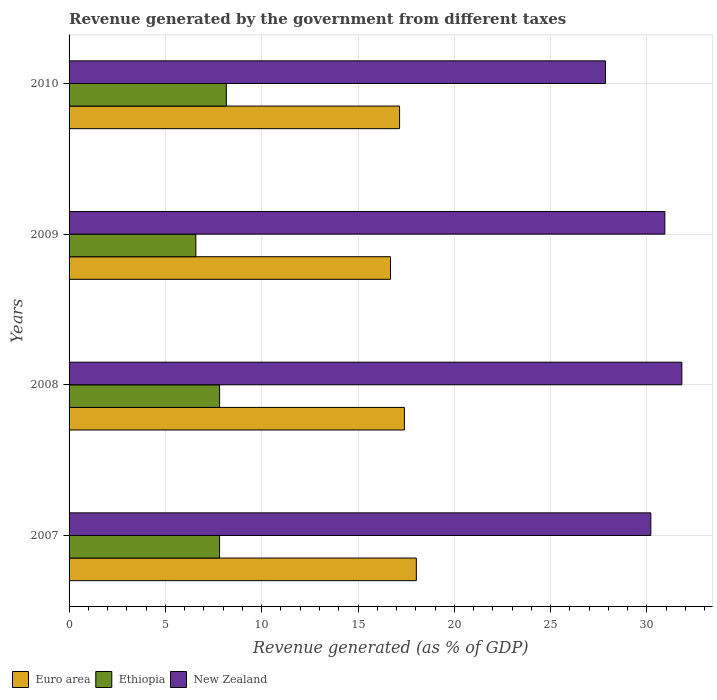How many different coloured bars are there?
Provide a succinct answer. 3. How many groups of bars are there?
Ensure brevity in your answer.  4. Are the number of bars per tick equal to the number of legend labels?
Your answer should be very brief. Yes. Are the number of bars on each tick of the Y-axis equal?
Your response must be concise. Yes. What is the label of the 2nd group of bars from the top?
Make the answer very short. 2009. In how many cases, is the number of bars for a given year not equal to the number of legend labels?
Make the answer very short. 0. What is the revenue generated by the government in Euro area in 2009?
Your answer should be compact. 16.69. Across all years, what is the maximum revenue generated by the government in Ethiopia?
Offer a very short reply. 8.16. Across all years, what is the minimum revenue generated by the government in Ethiopia?
Provide a succinct answer. 6.58. In which year was the revenue generated by the government in New Zealand minimum?
Give a very brief answer. 2010. What is the total revenue generated by the government in Euro area in the graph?
Provide a short and direct response. 69.28. What is the difference between the revenue generated by the government in New Zealand in 2007 and that in 2008?
Your answer should be compact. -1.61. What is the difference between the revenue generated by the government in Euro area in 2010 and the revenue generated by the government in Ethiopia in 2007?
Give a very brief answer. 9.35. What is the average revenue generated by the government in Euro area per year?
Ensure brevity in your answer.  17.32. In the year 2008, what is the difference between the revenue generated by the government in Ethiopia and revenue generated by the government in New Zealand?
Your answer should be very brief. -24. What is the ratio of the revenue generated by the government in New Zealand in 2007 to that in 2008?
Offer a very short reply. 0.95. Is the revenue generated by the government in Ethiopia in 2009 less than that in 2010?
Your response must be concise. Yes. Is the difference between the revenue generated by the government in Ethiopia in 2007 and 2009 greater than the difference between the revenue generated by the government in New Zealand in 2007 and 2009?
Provide a succinct answer. Yes. What is the difference between the highest and the second highest revenue generated by the government in Ethiopia?
Keep it short and to the point. 0.35. What is the difference between the highest and the lowest revenue generated by the government in Euro area?
Keep it short and to the point. 1.34. In how many years, is the revenue generated by the government in Ethiopia greater than the average revenue generated by the government in Ethiopia taken over all years?
Ensure brevity in your answer.  3. Is the sum of the revenue generated by the government in Ethiopia in 2007 and 2008 greater than the maximum revenue generated by the government in Euro area across all years?
Provide a succinct answer. No. What does the 1st bar from the top in 2007 represents?
Provide a short and direct response. New Zealand. What does the 2nd bar from the bottom in 2007 represents?
Offer a very short reply. Ethiopia. Are all the bars in the graph horizontal?
Provide a succinct answer. Yes. How many years are there in the graph?
Keep it short and to the point. 4. Are the values on the major ticks of X-axis written in scientific E-notation?
Your answer should be very brief. No. What is the title of the graph?
Ensure brevity in your answer.  Revenue generated by the government from different taxes. Does "Cyprus" appear as one of the legend labels in the graph?
Ensure brevity in your answer.  No. What is the label or title of the X-axis?
Provide a succinct answer. Revenue generated (as % of GDP). What is the label or title of the Y-axis?
Provide a short and direct response. Years. What is the Revenue generated (as % of GDP) in Euro area in 2007?
Your answer should be compact. 18.03. What is the Revenue generated (as % of GDP) in Ethiopia in 2007?
Ensure brevity in your answer.  7.81. What is the Revenue generated (as % of GDP) of New Zealand in 2007?
Make the answer very short. 30.2. What is the Revenue generated (as % of GDP) of Euro area in 2008?
Your response must be concise. 17.41. What is the Revenue generated (as % of GDP) of Ethiopia in 2008?
Your response must be concise. 7.81. What is the Revenue generated (as % of GDP) in New Zealand in 2008?
Give a very brief answer. 31.81. What is the Revenue generated (as % of GDP) in Euro area in 2009?
Offer a very short reply. 16.69. What is the Revenue generated (as % of GDP) in Ethiopia in 2009?
Give a very brief answer. 6.58. What is the Revenue generated (as % of GDP) in New Zealand in 2009?
Your answer should be very brief. 30.93. What is the Revenue generated (as % of GDP) in Euro area in 2010?
Your answer should be compact. 17.16. What is the Revenue generated (as % of GDP) in Ethiopia in 2010?
Give a very brief answer. 8.16. What is the Revenue generated (as % of GDP) in New Zealand in 2010?
Offer a terse response. 27.85. Across all years, what is the maximum Revenue generated (as % of GDP) of Euro area?
Your answer should be very brief. 18.03. Across all years, what is the maximum Revenue generated (as % of GDP) in Ethiopia?
Make the answer very short. 8.16. Across all years, what is the maximum Revenue generated (as % of GDP) in New Zealand?
Keep it short and to the point. 31.81. Across all years, what is the minimum Revenue generated (as % of GDP) of Euro area?
Your response must be concise. 16.69. Across all years, what is the minimum Revenue generated (as % of GDP) of Ethiopia?
Ensure brevity in your answer.  6.58. Across all years, what is the minimum Revenue generated (as % of GDP) of New Zealand?
Offer a very short reply. 27.85. What is the total Revenue generated (as % of GDP) in Euro area in the graph?
Make the answer very short. 69.28. What is the total Revenue generated (as % of GDP) of Ethiopia in the graph?
Ensure brevity in your answer.  30.37. What is the total Revenue generated (as % of GDP) in New Zealand in the graph?
Provide a short and direct response. 120.79. What is the difference between the Revenue generated (as % of GDP) of Euro area in 2007 and that in 2008?
Provide a short and direct response. 0.62. What is the difference between the Revenue generated (as % of GDP) in Ethiopia in 2007 and that in 2008?
Offer a terse response. -0. What is the difference between the Revenue generated (as % of GDP) in New Zealand in 2007 and that in 2008?
Your answer should be very brief. -1.61. What is the difference between the Revenue generated (as % of GDP) of Euro area in 2007 and that in 2009?
Keep it short and to the point. 1.34. What is the difference between the Revenue generated (as % of GDP) of Ethiopia in 2007 and that in 2009?
Your answer should be compact. 1.23. What is the difference between the Revenue generated (as % of GDP) of New Zealand in 2007 and that in 2009?
Your answer should be compact. -0.73. What is the difference between the Revenue generated (as % of GDP) in Euro area in 2007 and that in 2010?
Provide a succinct answer. 0.87. What is the difference between the Revenue generated (as % of GDP) of Ethiopia in 2007 and that in 2010?
Offer a very short reply. -0.35. What is the difference between the Revenue generated (as % of GDP) of New Zealand in 2007 and that in 2010?
Your answer should be compact. 2.35. What is the difference between the Revenue generated (as % of GDP) of Euro area in 2008 and that in 2009?
Give a very brief answer. 0.72. What is the difference between the Revenue generated (as % of GDP) in Ethiopia in 2008 and that in 2009?
Your response must be concise. 1.23. What is the difference between the Revenue generated (as % of GDP) in New Zealand in 2008 and that in 2009?
Offer a very short reply. 0.88. What is the difference between the Revenue generated (as % of GDP) in Euro area in 2008 and that in 2010?
Your answer should be compact. 0.25. What is the difference between the Revenue generated (as % of GDP) of Ethiopia in 2008 and that in 2010?
Offer a very short reply. -0.35. What is the difference between the Revenue generated (as % of GDP) of New Zealand in 2008 and that in 2010?
Your answer should be compact. 3.96. What is the difference between the Revenue generated (as % of GDP) in Euro area in 2009 and that in 2010?
Ensure brevity in your answer.  -0.47. What is the difference between the Revenue generated (as % of GDP) of Ethiopia in 2009 and that in 2010?
Make the answer very short. -1.58. What is the difference between the Revenue generated (as % of GDP) in New Zealand in 2009 and that in 2010?
Your answer should be very brief. 3.08. What is the difference between the Revenue generated (as % of GDP) in Euro area in 2007 and the Revenue generated (as % of GDP) in Ethiopia in 2008?
Provide a short and direct response. 10.21. What is the difference between the Revenue generated (as % of GDP) in Euro area in 2007 and the Revenue generated (as % of GDP) in New Zealand in 2008?
Make the answer very short. -13.78. What is the difference between the Revenue generated (as % of GDP) in Ethiopia in 2007 and the Revenue generated (as % of GDP) in New Zealand in 2008?
Ensure brevity in your answer.  -24. What is the difference between the Revenue generated (as % of GDP) in Euro area in 2007 and the Revenue generated (as % of GDP) in Ethiopia in 2009?
Your answer should be compact. 11.45. What is the difference between the Revenue generated (as % of GDP) of Euro area in 2007 and the Revenue generated (as % of GDP) of New Zealand in 2009?
Offer a terse response. -12.9. What is the difference between the Revenue generated (as % of GDP) of Ethiopia in 2007 and the Revenue generated (as % of GDP) of New Zealand in 2009?
Make the answer very short. -23.12. What is the difference between the Revenue generated (as % of GDP) in Euro area in 2007 and the Revenue generated (as % of GDP) in Ethiopia in 2010?
Your response must be concise. 9.86. What is the difference between the Revenue generated (as % of GDP) in Euro area in 2007 and the Revenue generated (as % of GDP) in New Zealand in 2010?
Your response must be concise. -9.82. What is the difference between the Revenue generated (as % of GDP) of Ethiopia in 2007 and the Revenue generated (as % of GDP) of New Zealand in 2010?
Give a very brief answer. -20.03. What is the difference between the Revenue generated (as % of GDP) in Euro area in 2008 and the Revenue generated (as % of GDP) in Ethiopia in 2009?
Give a very brief answer. 10.83. What is the difference between the Revenue generated (as % of GDP) of Euro area in 2008 and the Revenue generated (as % of GDP) of New Zealand in 2009?
Ensure brevity in your answer.  -13.52. What is the difference between the Revenue generated (as % of GDP) in Ethiopia in 2008 and the Revenue generated (as % of GDP) in New Zealand in 2009?
Your answer should be compact. -23.11. What is the difference between the Revenue generated (as % of GDP) in Euro area in 2008 and the Revenue generated (as % of GDP) in Ethiopia in 2010?
Ensure brevity in your answer.  9.24. What is the difference between the Revenue generated (as % of GDP) of Euro area in 2008 and the Revenue generated (as % of GDP) of New Zealand in 2010?
Provide a succinct answer. -10.44. What is the difference between the Revenue generated (as % of GDP) of Ethiopia in 2008 and the Revenue generated (as % of GDP) of New Zealand in 2010?
Provide a short and direct response. -20.03. What is the difference between the Revenue generated (as % of GDP) in Euro area in 2009 and the Revenue generated (as % of GDP) in Ethiopia in 2010?
Provide a succinct answer. 8.52. What is the difference between the Revenue generated (as % of GDP) in Euro area in 2009 and the Revenue generated (as % of GDP) in New Zealand in 2010?
Offer a very short reply. -11.16. What is the difference between the Revenue generated (as % of GDP) in Ethiopia in 2009 and the Revenue generated (as % of GDP) in New Zealand in 2010?
Your answer should be very brief. -21.27. What is the average Revenue generated (as % of GDP) of Euro area per year?
Your response must be concise. 17.32. What is the average Revenue generated (as % of GDP) of Ethiopia per year?
Offer a terse response. 7.59. What is the average Revenue generated (as % of GDP) in New Zealand per year?
Keep it short and to the point. 30.2. In the year 2007, what is the difference between the Revenue generated (as % of GDP) in Euro area and Revenue generated (as % of GDP) in Ethiopia?
Keep it short and to the point. 10.21. In the year 2007, what is the difference between the Revenue generated (as % of GDP) in Euro area and Revenue generated (as % of GDP) in New Zealand?
Your answer should be compact. -12.17. In the year 2007, what is the difference between the Revenue generated (as % of GDP) in Ethiopia and Revenue generated (as % of GDP) in New Zealand?
Your response must be concise. -22.39. In the year 2008, what is the difference between the Revenue generated (as % of GDP) of Euro area and Revenue generated (as % of GDP) of Ethiopia?
Keep it short and to the point. 9.59. In the year 2008, what is the difference between the Revenue generated (as % of GDP) in Euro area and Revenue generated (as % of GDP) in New Zealand?
Ensure brevity in your answer.  -14.4. In the year 2008, what is the difference between the Revenue generated (as % of GDP) in Ethiopia and Revenue generated (as % of GDP) in New Zealand?
Provide a succinct answer. -24. In the year 2009, what is the difference between the Revenue generated (as % of GDP) in Euro area and Revenue generated (as % of GDP) in Ethiopia?
Give a very brief answer. 10.11. In the year 2009, what is the difference between the Revenue generated (as % of GDP) in Euro area and Revenue generated (as % of GDP) in New Zealand?
Your answer should be very brief. -14.24. In the year 2009, what is the difference between the Revenue generated (as % of GDP) in Ethiopia and Revenue generated (as % of GDP) in New Zealand?
Your response must be concise. -24.35. In the year 2010, what is the difference between the Revenue generated (as % of GDP) of Euro area and Revenue generated (as % of GDP) of Ethiopia?
Your answer should be very brief. 8.99. In the year 2010, what is the difference between the Revenue generated (as % of GDP) of Euro area and Revenue generated (as % of GDP) of New Zealand?
Provide a short and direct response. -10.69. In the year 2010, what is the difference between the Revenue generated (as % of GDP) in Ethiopia and Revenue generated (as % of GDP) in New Zealand?
Give a very brief answer. -19.68. What is the ratio of the Revenue generated (as % of GDP) of Euro area in 2007 to that in 2008?
Ensure brevity in your answer.  1.04. What is the ratio of the Revenue generated (as % of GDP) in Ethiopia in 2007 to that in 2008?
Offer a terse response. 1. What is the ratio of the Revenue generated (as % of GDP) of New Zealand in 2007 to that in 2008?
Offer a terse response. 0.95. What is the ratio of the Revenue generated (as % of GDP) in Euro area in 2007 to that in 2009?
Offer a terse response. 1.08. What is the ratio of the Revenue generated (as % of GDP) of Ethiopia in 2007 to that in 2009?
Your answer should be compact. 1.19. What is the ratio of the Revenue generated (as % of GDP) in New Zealand in 2007 to that in 2009?
Your answer should be compact. 0.98. What is the ratio of the Revenue generated (as % of GDP) in Euro area in 2007 to that in 2010?
Provide a short and direct response. 1.05. What is the ratio of the Revenue generated (as % of GDP) in New Zealand in 2007 to that in 2010?
Your answer should be compact. 1.08. What is the ratio of the Revenue generated (as % of GDP) in Euro area in 2008 to that in 2009?
Your answer should be compact. 1.04. What is the ratio of the Revenue generated (as % of GDP) of Ethiopia in 2008 to that in 2009?
Keep it short and to the point. 1.19. What is the ratio of the Revenue generated (as % of GDP) in New Zealand in 2008 to that in 2009?
Keep it short and to the point. 1.03. What is the ratio of the Revenue generated (as % of GDP) of Euro area in 2008 to that in 2010?
Offer a very short reply. 1.01. What is the ratio of the Revenue generated (as % of GDP) in Ethiopia in 2008 to that in 2010?
Provide a succinct answer. 0.96. What is the ratio of the Revenue generated (as % of GDP) of New Zealand in 2008 to that in 2010?
Ensure brevity in your answer.  1.14. What is the ratio of the Revenue generated (as % of GDP) of Euro area in 2009 to that in 2010?
Give a very brief answer. 0.97. What is the ratio of the Revenue generated (as % of GDP) of Ethiopia in 2009 to that in 2010?
Make the answer very short. 0.81. What is the ratio of the Revenue generated (as % of GDP) of New Zealand in 2009 to that in 2010?
Your response must be concise. 1.11. What is the difference between the highest and the second highest Revenue generated (as % of GDP) in Euro area?
Give a very brief answer. 0.62. What is the difference between the highest and the second highest Revenue generated (as % of GDP) in Ethiopia?
Give a very brief answer. 0.35. What is the difference between the highest and the second highest Revenue generated (as % of GDP) in New Zealand?
Keep it short and to the point. 0.88. What is the difference between the highest and the lowest Revenue generated (as % of GDP) of Euro area?
Provide a short and direct response. 1.34. What is the difference between the highest and the lowest Revenue generated (as % of GDP) in Ethiopia?
Ensure brevity in your answer.  1.58. What is the difference between the highest and the lowest Revenue generated (as % of GDP) in New Zealand?
Give a very brief answer. 3.96. 